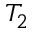<formula> <loc_0><loc_0><loc_500><loc_500>T _ { 2 }</formula> 